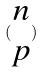<formula> <loc_0><loc_0><loc_500><loc_500>( \begin{matrix} n \\ p \end{matrix} )</formula> 